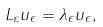<formula> <loc_0><loc_0><loc_500><loc_500>L _ { \varepsilon } u _ { \epsilon } = \lambda _ { \epsilon } u _ { \epsilon } ,</formula> 